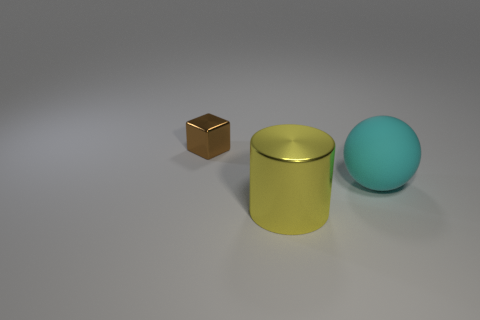There is a metal thing to the right of the shiny thing that is behind the large object behind the large yellow metallic cylinder; what color is it?
Offer a terse response. Yellow. There is a thing that is to the left of the yellow cylinder; does it have the same color as the matte thing?
Keep it short and to the point. No. What number of objects are both on the left side of the big cyan matte thing and behind the large yellow object?
Give a very brief answer. 1. What number of large metallic objects are right of the metal object on the left side of the shiny object in front of the tiny metallic cube?
Offer a terse response. 1. There is a thing that is on the left side of the shiny thing that is to the right of the brown shiny cube; what is its color?
Provide a short and direct response. Brown. How many other objects are the same material as the cyan sphere?
Your response must be concise. 0. What number of large matte balls are left of the shiny object on the right side of the small brown object?
Make the answer very short. 0. Is there any other thing that is the same shape as the tiny metallic thing?
Offer a terse response. No. Does the metal thing that is in front of the brown block have the same color as the metal thing that is left of the big cylinder?
Your answer should be compact. No. Is the number of yellow cylinders less than the number of large blue balls?
Offer a terse response. No. 